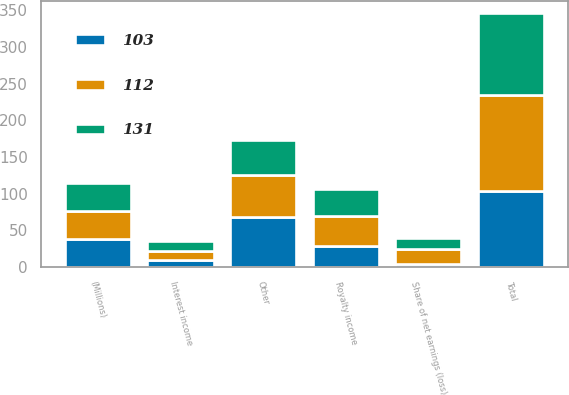Convert chart. <chart><loc_0><loc_0><loc_500><loc_500><stacked_bar_chart><ecel><fcel>(Millions)<fcel>Interest income<fcel>Royalty income<fcel>Share of net earnings (loss)<fcel>Other<fcel>Total<nl><fcel>131<fcel>38<fcel>13<fcel>38<fcel>14<fcel>47<fcel>112<nl><fcel>112<fcel>38<fcel>12<fcel>40<fcel>21<fcel>58<fcel>131<nl><fcel>103<fcel>38<fcel>10<fcel>29<fcel>4<fcel>68<fcel>103<nl></chart> 